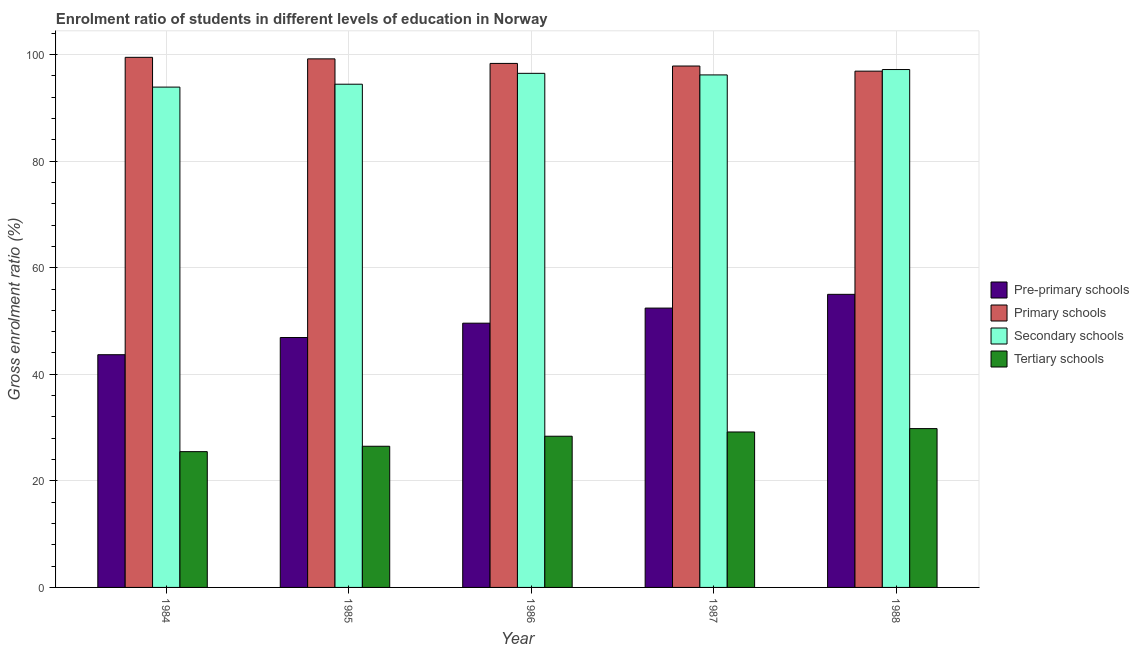How many groups of bars are there?
Offer a terse response. 5. How many bars are there on the 3rd tick from the left?
Give a very brief answer. 4. How many bars are there on the 3rd tick from the right?
Ensure brevity in your answer.  4. What is the label of the 4th group of bars from the left?
Keep it short and to the point. 1987. In how many cases, is the number of bars for a given year not equal to the number of legend labels?
Provide a succinct answer. 0. What is the gross enrolment ratio in tertiary schools in 1987?
Provide a succinct answer. 29.17. Across all years, what is the maximum gross enrolment ratio in primary schools?
Offer a very short reply. 99.49. Across all years, what is the minimum gross enrolment ratio in secondary schools?
Your answer should be compact. 93.91. What is the total gross enrolment ratio in primary schools in the graph?
Give a very brief answer. 491.81. What is the difference between the gross enrolment ratio in pre-primary schools in 1984 and that in 1985?
Offer a very short reply. -3.23. What is the difference between the gross enrolment ratio in primary schools in 1984 and the gross enrolment ratio in tertiary schools in 1987?
Provide a succinct answer. 1.63. What is the average gross enrolment ratio in secondary schools per year?
Offer a very short reply. 95.65. In the year 1984, what is the difference between the gross enrolment ratio in secondary schools and gross enrolment ratio in pre-primary schools?
Keep it short and to the point. 0. In how many years, is the gross enrolment ratio in primary schools greater than 20 %?
Your answer should be compact. 5. What is the ratio of the gross enrolment ratio in secondary schools in 1984 to that in 1985?
Give a very brief answer. 0.99. Is the difference between the gross enrolment ratio in tertiary schools in 1984 and 1988 greater than the difference between the gross enrolment ratio in primary schools in 1984 and 1988?
Your answer should be compact. No. What is the difference between the highest and the second highest gross enrolment ratio in tertiary schools?
Provide a short and direct response. 0.64. What is the difference between the highest and the lowest gross enrolment ratio in pre-primary schools?
Your answer should be compact. 11.33. In how many years, is the gross enrolment ratio in secondary schools greater than the average gross enrolment ratio in secondary schools taken over all years?
Offer a terse response. 3. Is it the case that in every year, the sum of the gross enrolment ratio in pre-primary schools and gross enrolment ratio in primary schools is greater than the sum of gross enrolment ratio in tertiary schools and gross enrolment ratio in secondary schools?
Provide a succinct answer. Yes. What does the 2nd bar from the left in 1987 represents?
Provide a short and direct response. Primary schools. What does the 4th bar from the right in 1984 represents?
Your answer should be very brief. Pre-primary schools. Is it the case that in every year, the sum of the gross enrolment ratio in pre-primary schools and gross enrolment ratio in primary schools is greater than the gross enrolment ratio in secondary schools?
Your answer should be compact. Yes. Are the values on the major ticks of Y-axis written in scientific E-notation?
Keep it short and to the point. No. Does the graph contain grids?
Give a very brief answer. Yes. Where does the legend appear in the graph?
Provide a short and direct response. Center right. How are the legend labels stacked?
Your answer should be very brief. Vertical. What is the title of the graph?
Keep it short and to the point. Enrolment ratio of students in different levels of education in Norway. What is the Gross enrolment ratio (%) of Pre-primary schools in 1984?
Offer a terse response. 43.68. What is the Gross enrolment ratio (%) of Primary schools in 1984?
Provide a succinct answer. 99.49. What is the Gross enrolment ratio (%) in Secondary schools in 1984?
Give a very brief answer. 93.91. What is the Gross enrolment ratio (%) in Tertiary schools in 1984?
Offer a very short reply. 25.48. What is the Gross enrolment ratio (%) in Pre-primary schools in 1985?
Give a very brief answer. 46.9. What is the Gross enrolment ratio (%) of Primary schools in 1985?
Your answer should be compact. 99.2. What is the Gross enrolment ratio (%) of Secondary schools in 1985?
Your response must be concise. 94.45. What is the Gross enrolment ratio (%) of Tertiary schools in 1985?
Your answer should be very brief. 26.5. What is the Gross enrolment ratio (%) of Pre-primary schools in 1986?
Give a very brief answer. 49.6. What is the Gross enrolment ratio (%) in Primary schools in 1986?
Your answer should be very brief. 98.35. What is the Gross enrolment ratio (%) of Secondary schools in 1986?
Give a very brief answer. 96.49. What is the Gross enrolment ratio (%) of Tertiary schools in 1986?
Provide a succinct answer. 28.38. What is the Gross enrolment ratio (%) of Pre-primary schools in 1987?
Your answer should be very brief. 52.43. What is the Gross enrolment ratio (%) of Primary schools in 1987?
Offer a very short reply. 97.86. What is the Gross enrolment ratio (%) of Secondary schools in 1987?
Keep it short and to the point. 96.19. What is the Gross enrolment ratio (%) in Tertiary schools in 1987?
Your response must be concise. 29.17. What is the Gross enrolment ratio (%) of Pre-primary schools in 1988?
Keep it short and to the point. 55.01. What is the Gross enrolment ratio (%) of Primary schools in 1988?
Ensure brevity in your answer.  96.9. What is the Gross enrolment ratio (%) in Secondary schools in 1988?
Your answer should be compact. 97.2. What is the Gross enrolment ratio (%) of Tertiary schools in 1988?
Provide a short and direct response. 29.81. Across all years, what is the maximum Gross enrolment ratio (%) of Pre-primary schools?
Keep it short and to the point. 55.01. Across all years, what is the maximum Gross enrolment ratio (%) in Primary schools?
Offer a very short reply. 99.49. Across all years, what is the maximum Gross enrolment ratio (%) of Secondary schools?
Give a very brief answer. 97.2. Across all years, what is the maximum Gross enrolment ratio (%) in Tertiary schools?
Your answer should be very brief. 29.81. Across all years, what is the minimum Gross enrolment ratio (%) in Pre-primary schools?
Provide a short and direct response. 43.68. Across all years, what is the minimum Gross enrolment ratio (%) of Primary schools?
Your answer should be compact. 96.9. Across all years, what is the minimum Gross enrolment ratio (%) in Secondary schools?
Provide a succinct answer. 93.91. Across all years, what is the minimum Gross enrolment ratio (%) of Tertiary schools?
Your response must be concise. 25.48. What is the total Gross enrolment ratio (%) of Pre-primary schools in the graph?
Make the answer very short. 247.62. What is the total Gross enrolment ratio (%) of Primary schools in the graph?
Your answer should be very brief. 491.81. What is the total Gross enrolment ratio (%) in Secondary schools in the graph?
Your response must be concise. 478.23. What is the total Gross enrolment ratio (%) of Tertiary schools in the graph?
Keep it short and to the point. 139.34. What is the difference between the Gross enrolment ratio (%) of Pre-primary schools in 1984 and that in 1985?
Offer a terse response. -3.23. What is the difference between the Gross enrolment ratio (%) in Primary schools in 1984 and that in 1985?
Provide a succinct answer. 0.29. What is the difference between the Gross enrolment ratio (%) of Secondary schools in 1984 and that in 1985?
Your response must be concise. -0.54. What is the difference between the Gross enrolment ratio (%) in Tertiary schools in 1984 and that in 1985?
Provide a short and direct response. -1.01. What is the difference between the Gross enrolment ratio (%) of Pre-primary schools in 1984 and that in 1986?
Provide a short and direct response. -5.92. What is the difference between the Gross enrolment ratio (%) in Primary schools in 1984 and that in 1986?
Offer a terse response. 1.14. What is the difference between the Gross enrolment ratio (%) in Secondary schools in 1984 and that in 1986?
Keep it short and to the point. -2.58. What is the difference between the Gross enrolment ratio (%) in Tertiary schools in 1984 and that in 1986?
Provide a short and direct response. -2.9. What is the difference between the Gross enrolment ratio (%) in Pre-primary schools in 1984 and that in 1987?
Ensure brevity in your answer.  -8.75. What is the difference between the Gross enrolment ratio (%) in Primary schools in 1984 and that in 1987?
Offer a terse response. 1.63. What is the difference between the Gross enrolment ratio (%) in Secondary schools in 1984 and that in 1987?
Give a very brief answer. -2.29. What is the difference between the Gross enrolment ratio (%) of Tertiary schools in 1984 and that in 1987?
Make the answer very short. -3.69. What is the difference between the Gross enrolment ratio (%) in Pre-primary schools in 1984 and that in 1988?
Ensure brevity in your answer.  -11.33. What is the difference between the Gross enrolment ratio (%) in Primary schools in 1984 and that in 1988?
Ensure brevity in your answer.  2.59. What is the difference between the Gross enrolment ratio (%) of Secondary schools in 1984 and that in 1988?
Your answer should be compact. -3.29. What is the difference between the Gross enrolment ratio (%) in Tertiary schools in 1984 and that in 1988?
Your response must be concise. -4.33. What is the difference between the Gross enrolment ratio (%) in Pre-primary schools in 1985 and that in 1986?
Provide a short and direct response. -2.69. What is the difference between the Gross enrolment ratio (%) of Primary schools in 1985 and that in 1986?
Offer a very short reply. 0.85. What is the difference between the Gross enrolment ratio (%) of Secondary schools in 1985 and that in 1986?
Your answer should be compact. -2.04. What is the difference between the Gross enrolment ratio (%) of Tertiary schools in 1985 and that in 1986?
Provide a short and direct response. -1.88. What is the difference between the Gross enrolment ratio (%) of Pre-primary schools in 1985 and that in 1987?
Make the answer very short. -5.52. What is the difference between the Gross enrolment ratio (%) in Primary schools in 1985 and that in 1987?
Make the answer very short. 1.34. What is the difference between the Gross enrolment ratio (%) in Secondary schools in 1985 and that in 1987?
Make the answer very short. -1.75. What is the difference between the Gross enrolment ratio (%) of Tertiary schools in 1985 and that in 1987?
Offer a very short reply. -2.68. What is the difference between the Gross enrolment ratio (%) of Pre-primary schools in 1985 and that in 1988?
Give a very brief answer. -8.1. What is the difference between the Gross enrolment ratio (%) of Primary schools in 1985 and that in 1988?
Make the answer very short. 2.31. What is the difference between the Gross enrolment ratio (%) of Secondary schools in 1985 and that in 1988?
Your answer should be compact. -2.75. What is the difference between the Gross enrolment ratio (%) in Tertiary schools in 1985 and that in 1988?
Your answer should be compact. -3.31. What is the difference between the Gross enrolment ratio (%) in Pre-primary schools in 1986 and that in 1987?
Offer a very short reply. -2.83. What is the difference between the Gross enrolment ratio (%) of Primary schools in 1986 and that in 1987?
Provide a short and direct response. 0.49. What is the difference between the Gross enrolment ratio (%) in Secondary schools in 1986 and that in 1987?
Give a very brief answer. 0.29. What is the difference between the Gross enrolment ratio (%) of Tertiary schools in 1986 and that in 1987?
Give a very brief answer. -0.8. What is the difference between the Gross enrolment ratio (%) of Pre-primary schools in 1986 and that in 1988?
Keep it short and to the point. -5.41. What is the difference between the Gross enrolment ratio (%) of Primary schools in 1986 and that in 1988?
Your answer should be compact. 1.45. What is the difference between the Gross enrolment ratio (%) of Secondary schools in 1986 and that in 1988?
Give a very brief answer. -0.71. What is the difference between the Gross enrolment ratio (%) of Tertiary schools in 1986 and that in 1988?
Make the answer very short. -1.43. What is the difference between the Gross enrolment ratio (%) of Pre-primary schools in 1987 and that in 1988?
Your answer should be compact. -2.58. What is the difference between the Gross enrolment ratio (%) in Primary schools in 1987 and that in 1988?
Your answer should be compact. 0.96. What is the difference between the Gross enrolment ratio (%) of Secondary schools in 1987 and that in 1988?
Your answer should be compact. -1.01. What is the difference between the Gross enrolment ratio (%) of Tertiary schools in 1987 and that in 1988?
Your answer should be very brief. -0.64. What is the difference between the Gross enrolment ratio (%) of Pre-primary schools in 1984 and the Gross enrolment ratio (%) of Primary schools in 1985?
Keep it short and to the point. -55.53. What is the difference between the Gross enrolment ratio (%) in Pre-primary schools in 1984 and the Gross enrolment ratio (%) in Secondary schools in 1985?
Ensure brevity in your answer.  -50.77. What is the difference between the Gross enrolment ratio (%) in Pre-primary schools in 1984 and the Gross enrolment ratio (%) in Tertiary schools in 1985?
Offer a terse response. 17.18. What is the difference between the Gross enrolment ratio (%) of Primary schools in 1984 and the Gross enrolment ratio (%) of Secondary schools in 1985?
Offer a terse response. 5.04. What is the difference between the Gross enrolment ratio (%) in Primary schools in 1984 and the Gross enrolment ratio (%) in Tertiary schools in 1985?
Your answer should be compact. 73. What is the difference between the Gross enrolment ratio (%) in Secondary schools in 1984 and the Gross enrolment ratio (%) in Tertiary schools in 1985?
Ensure brevity in your answer.  67.41. What is the difference between the Gross enrolment ratio (%) of Pre-primary schools in 1984 and the Gross enrolment ratio (%) of Primary schools in 1986?
Offer a very short reply. -54.67. What is the difference between the Gross enrolment ratio (%) of Pre-primary schools in 1984 and the Gross enrolment ratio (%) of Secondary schools in 1986?
Make the answer very short. -52.81. What is the difference between the Gross enrolment ratio (%) of Pre-primary schools in 1984 and the Gross enrolment ratio (%) of Tertiary schools in 1986?
Your answer should be compact. 15.3. What is the difference between the Gross enrolment ratio (%) in Primary schools in 1984 and the Gross enrolment ratio (%) in Secondary schools in 1986?
Provide a short and direct response. 3.01. What is the difference between the Gross enrolment ratio (%) in Primary schools in 1984 and the Gross enrolment ratio (%) in Tertiary schools in 1986?
Provide a short and direct response. 71.11. What is the difference between the Gross enrolment ratio (%) of Secondary schools in 1984 and the Gross enrolment ratio (%) of Tertiary schools in 1986?
Your response must be concise. 65.53. What is the difference between the Gross enrolment ratio (%) in Pre-primary schools in 1984 and the Gross enrolment ratio (%) in Primary schools in 1987?
Ensure brevity in your answer.  -54.18. What is the difference between the Gross enrolment ratio (%) of Pre-primary schools in 1984 and the Gross enrolment ratio (%) of Secondary schools in 1987?
Make the answer very short. -52.51. What is the difference between the Gross enrolment ratio (%) of Pre-primary schools in 1984 and the Gross enrolment ratio (%) of Tertiary schools in 1987?
Keep it short and to the point. 14.5. What is the difference between the Gross enrolment ratio (%) of Primary schools in 1984 and the Gross enrolment ratio (%) of Secondary schools in 1987?
Provide a succinct answer. 3.3. What is the difference between the Gross enrolment ratio (%) in Primary schools in 1984 and the Gross enrolment ratio (%) in Tertiary schools in 1987?
Offer a terse response. 70.32. What is the difference between the Gross enrolment ratio (%) in Secondary schools in 1984 and the Gross enrolment ratio (%) in Tertiary schools in 1987?
Provide a short and direct response. 64.73. What is the difference between the Gross enrolment ratio (%) in Pre-primary schools in 1984 and the Gross enrolment ratio (%) in Primary schools in 1988?
Ensure brevity in your answer.  -53.22. What is the difference between the Gross enrolment ratio (%) of Pre-primary schools in 1984 and the Gross enrolment ratio (%) of Secondary schools in 1988?
Give a very brief answer. -53.52. What is the difference between the Gross enrolment ratio (%) in Pre-primary schools in 1984 and the Gross enrolment ratio (%) in Tertiary schools in 1988?
Keep it short and to the point. 13.87. What is the difference between the Gross enrolment ratio (%) of Primary schools in 1984 and the Gross enrolment ratio (%) of Secondary schools in 1988?
Your answer should be compact. 2.29. What is the difference between the Gross enrolment ratio (%) of Primary schools in 1984 and the Gross enrolment ratio (%) of Tertiary schools in 1988?
Your response must be concise. 69.68. What is the difference between the Gross enrolment ratio (%) of Secondary schools in 1984 and the Gross enrolment ratio (%) of Tertiary schools in 1988?
Your answer should be compact. 64.1. What is the difference between the Gross enrolment ratio (%) in Pre-primary schools in 1985 and the Gross enrolment ratio (%) in Primary schools in 1986?
Your response must be concise. -51.45. What is the difference between the Gross enrolment ratio (%) in Pre-primary schools in 1985 and the Gross enrolment ratio (%) in Secondary schools in 1986?
Offer a very short reply. -49.58. What is the difference between the Gross enrolment ratio (%) of Pre-primary schools in 1985 and the Gross enrolment ratio (%) of Tertiary schools in 1986?
Ensure brevity in your answer.  18.53. What is the difference between the Gross enrolment ratio (%) of Primary schools in 1985 and the Gross enrolment ratio (%) of Secondary schools in 1986?
Provide a short and direct response. 2.72. What is the difference between the Gross enrolment ratio (%) of Primary schools in 1985 and the Gross enrolment ratio (%) of Tertiary schools in 1986?
Keep it short and to the point. 70.82. What is the difference between the Gross enrolment ratio (%) of Secondary schools in 1985 and the Gross enrolment ratio (%) of Tertiary schools in 1986?
Offer a very short reply. 66.07. What is the difference between the Gross enrolment ratio (%) in Pre-primary schools in 1985 and the Gross enrolment ratio (%) in Primary schools in 1987?
Provide a succinct answer. -50.96. What is the difference between the Gross enrolment ratio (%) in Pre-primary schools in 1985 and the Gross enrolment ratio (%) in Secondary schools in 1987?
Your answer should be very brief. -49.29. What is the difference between the Gross enrolment ratio (%) in Pre-primary schools in 1985 and the Gross enrolment ratio (%) in Tertiary schools in 1987?
Provide a succinct answer. 17.73. What is the difference between the Gross enrolment ratio (%) of Primary schools in 1985 and the Gross enrolment ratio (%) of Secondary schools in 1987?
Offer a very short reply. 3.01. What is the difference between the Gross enrolment ratio (%) in Primary schools in 1985 and the Gross enrolment ratio (%) in Tertiary schools in 1987?
Your answer should be compact. 70.03. What is the difference between the Gross enrolment ratio (%) in Secondary schools in 1985 and the Gross enrolment ratio (%) in Tertiary schools in 1987?
Your response must be concise. 65.27. What is the difference between the Gross enrolment ratio (%) in Pre-primary schools in 1985 and the Gross enrolment ratio (%) in Primary schools in 1988?
Your response must be concise. -49.99. What is the difference between the Gross enrolment ratio (%) of Pre-primary schools in 1985 and the Gross enrolment ratio (%) of Secondary schools in 1988?
Provide a short and direct response. -50.3. What is the difference between the Gross enrolment ratio (%) in Pre-primary schools in 1985 and the Gross enrolment ratio (%) in Tertiary schools in 1988?
Your response must be concise. 17.09. What is the difference between the Gross enrolment ratio (%) of Primary schools in 1985 and the Gross enrolment ratio (%) of Secondary schools in 1988?
Offer a very short reply. 2. What is the difference between the Gross enrolment ratio (%) in Primary schools in 1985 and the Gross enrolment ratio (%) in Tertiary schools in 1988?
Provide a short and direct response. 69.39. What is the difference between the Gross enrolment ratio (%) in Secondary schools in 1985 and the Gross enrolment ratio (%) in Tertiary schools in 1988?
Your answer should be compact. 64.64. What is the difference between the Gross enrolment ratio (%) of Pre-primary schools in 1986 and the Gross enrolment ratio (%) of Primary schools in 1987?
Ensure brevity in your answer.  -48.27. What is the difference between the Gross enrolment ratio (%) of Pre-primary schools in 1986 and the Gross enrolment ratio (%) of Secondary schools in 1987?
Offer a terse response. -46.6. What is the difference between the Gross enrolment ratio (%) in Pre-primary schools in 1986 and the Gross enrolment ratio (%) in Tertiary schools in 1987?
Ensure brevity in your answer.  20.42. What is the difference between the Gross enrolment ratio (%) in Primary schools in 1986 and the Gross enrolment ratio (%) in Secondary schools in 1987?
Keep it short and to the point. 2.16. What is the difference between the Gross enrolment ratio (%) in Primary schools in 1986 and the Gross enrolment ratio (%) in Tertiary schools in 1987?
Give a very brief answer. 69.18. What is the difference between the Gross enrolment ratio (%) of Secondary schools in 1986 and the Gross enrolment ratio (%) of Tertiary schools in 1987?
Your response must be concise. 67.31. What is the difference between the Gross enrolment ratio (%) in Pre-primary schools in 1986 and the Gross enrolment ratio (%) in Primary schools in 1988?
Your answer should be very brief. -47.3. What is the difference between the Gross enrolment ratio (%) in Pre-primary schools in 1986 and the Gross enrolment ratio (%) in Secondary schools in 1988?
Provide a short and direct response. -47.6. What is the difference between the Gross enrolment ratio (%) of Pre-primary schools in 1986 and the Gross enrolment ratio (%) of Tertiary schools in 1988?
Your answer should be compact. 19.79. What is the difference between the Gross enrolment ratio (%) in Primary schools in 1986 and the Gross enrolment ratio (%) in Secondary schools in 1988?
Offer a terse response. 1.15. What is the difference between the Gross enrolment ratio (%) of Primary schools in 1986 and the Gross enrolment ratio (%) of Tertiary schools in 1988?
Provide a succinct answer. 68.54. What is the difference between the Gross enrolment ratio (%) in Secondary schools in 1986 and the Gross enrolment ratio (%) in Tertiary schools in 1988?
Your answer should be very brief. 66.68. What is the difference between the Gross enrolment ratio (%) in Pre-primary schools in 1987 and the Gross enrolment ratio (%) in Primary schools in 1988?
Your answer should be compact. -44.47. What is the difference between the Gross enrolment ratio (%) of Pre-primary schools in 1987 and the Gross enrolment ratio (%) of Secondary schools in 1988?
Your response must be concise. -44.77. What is the difference between the Gross enrolment ratio (%) in Pre-primary schools in 1987 and the Gross enrolment ratio (%) in Tertiary schools in 1988?
Offer a very short reply. 22.62. What is the difference between the Gross enrolment ratio (%) in Primary schools in 1987 and the Gross enrolment ratio (%) in Secondary schools in 1988?
Your answer should be compact. 0.66. What is the difference between the Gross enrolment ratio (%) in Primary schools in 1987 and the Gross enrolment ratio (%) in Tertiary schools in 1988?
Offer a terse response. 68.05. What is the difference between the Gross enrolment ratio (%) of Secondary schools in 1987 and the Gross enrolment ratio (%) of Tertiary schools in 1988?
Offer a very short reply. 66.38. What is the average Gross enrolment ratio (%) of Pre-primary schools per year?
Provide a short and direct response. 49.52. What is the average Gross enrolment ratio (%) of Primary schools per year?
Your answer should be compact. 98.36. What is the average Gross enrolment ratio (%) in Secondary schools per year?
Keep it short and to the point. 95.65. What is the average Gross enrolment ratio (%) of Tertiary schools per year?
Make the answer very short. 27.87. In the year 1984, what is the difference between the Gross enrolment ratio (%) in Pre-primary schools and Gross enrolment ratio (%) in Primary schools?
Keep it short and to the point. -55.81. In the year 1984, what is the difference between the Gross enrolment ratio (%) of Pre-primary schools and Gross enrolment ratio (%) of Secondary schools?
Your answer should be compact. -50.23. In the year 1984, what is the difference between the Gross enrolment ratio (%) of Pre-primary schools and Gross enrolment ratio (%) of Tertiary schools?
Offer a terse response. 18.19. In the year 1984, what is the difference between the Gross enrolment ratio (%) of Primary schools and Gross enrolment ratio (%) of Secondary schools?
Give a very brief answer. 5.59. In the year 1984, what is the difference between the Gross enrolment ratio (%) in Primary schools and Gross enrolment ratio (%) in Tertiary schools?
Provide a succinct answer. 74.01. In the year 1984, what is the difference between the Gross enrolment ratio (%) in Secondary schools and Gross enrolment ratio (%) in Tertiary schools?
Your response must be concise. 68.42. In the year 1985, what is the difference between the Gross enrolment ratio (%) of Pre-primary schools and Gross enrolment ratio (%) of Primary schools?
Offer a very short reply. -52.3. In the year 1985, what is the difference between the Gross enrolment ratio (%) in Pre-primary schools and Gross enrolment ratio (%) in Secondary schools?
Provide a succinct answer. -47.54. In the year 1985, what is the difference between the Gross enrolment ratio (%) of Pre-primary schools and Gross enrolment ratio (%) of Tertiary schools?
Make the answer very short. 20.41. In the year 1985, what is the difference between the Gross enrolment ratio (%) in Primary schools and Gross enrolment ratio (%) in Secondary schools?
Your answer should be very brief. 4.76. In the year 1985, what is the difference between the Gross enrolment ratio (%) of Primary schools and Gross enrolment ratio (%) of Tertiary schools?
Offer a very short reply. 72.71. In the year 1985, what is the difference between the Gross enrolment ratio (%) of Secondary schools and Gross enrolment ratio (%) of Tertiary schools?
Provide a short and direct response. 67.95. In the year 1986, what is the difference between the Gross enrolment ratio (%) of Pre-primary schools and Gross enrolment ratio (%) of Primary schools?
Offer a terse response. -48.75. In the year 1986, what is the difference between the Gross enrolment ratio (%) in Pre-primary schools and Gross enrolment ratio (%) in Secondary schools?
Your answer should be compact. -46.89. In the year 1986, what is the difference between the Gross enrolment ratio (%) of Pre-primary schools and Gross enrolment ratio (%) of Tertiary schools?
Provide a short and direct response. 21.22. In the year 1986, what is the difference between the Gross enrolment ratio (%) of Primary schools and Gross enrolment ratio (%) of Secondary schools?
Your answer should be very brief. 1.86. In the year 1986, what is the difference between the Gross enrolment ratio (%) of Primary schools and Gross enrolment ratio (%) of Tertiary schools?
Ensure brevity in your answer.  69.97. In the year 1986, what is the difference between the Gross enrolment ratio (%) of Secondary schools and Gross enrolment ratio (%) of Tertiary schools?
Ensure brevity in your answer.  68.11. In the year 1987, what is the difference between the Gross enrolment ratio (%) in Pre-primary schools and Gross enrolment ratio (%) in Primary schools?
Offer a very short reply. -45.43. In the year 1987, what is the difference between the Gross enrolment ratio (%) of Pre-primary schools and Gross enrolment ratio (%) of Secondary schools?
Ensure brevity in your answer.  -43.76. In the year 1987, what is the difference between the Gross enrolment ratio (%) in Pre-primary schools and Gross enrolment ratio (%) in Tertiary schools?
Give a very brief answer. 23.25. In the year 1987, what is the difference between the Gross enrolment ratio (%) in Primary schools and Gross enrolment ratio (%) in Secondary schools?
Provide a succinct answer. 1.67. In the year 1987, what is the difference between the Gross enrolment ratio (%) in Primary schools and Gross enrolment ratio (%) in Tertiary schools?
Your response must be concise. 68.69. In the year 1987, what is the difference between the Gross enrolment ratio (%) in Secondary schools and Gross enrolment ratio (%) in Tertiary schools?
Your answer should be very brief. 67.02. In the year 1988, what is the difference between the Gross enrolment ratio (%) in Pre-primary schools and Gross enrolment ratio (%) in Primary schools?
Give a very brief answer. -41.89. In the year 1988, what is the difference between the Gross enrolment ratio (%) of Pre-primary schools and Gross enrolment ratio (%) of Secondary schools?
Provide a short and direct response. -42.19. In the year 1988, what is the difference between the Gross enrolment ratio (%) in Pre-primary schools and Gross enrolment ratio (%) in Tertiary schools?
Make the answer very short. 25.2. In the year 1988, what is the difference between the Gross enrolment ratio (%) of Primary schools and Gross enrolment ratio (%) of Secondary schools?
Your response must be concise. -0.3. In the year 1988, what is the difference between the Gross enrolment ratio (%) in Primary schools and Gross enrolment ratio (%) in Tertiary schools?
Your answer should be very brief. 67.09. In the year 1988, what is the difference between the Gross enrolment ratio (%) of Secondary schools and Gross enrolment ratio (%) of Tertiary schools?
Your response must be concise. 67.39. What is the ratio of the Gross enrolment ratio (%) of Pre-primary schools in 1984 to that in 1985?
Make the answer very short. 0.93. What is the ratio of the Gross enrolment ratio (%) of Primary schools in 1984 to that in 1985?
Provide a succinct answer. 1. What is the ratio of the Gross enrolment ratio (%) in Secondary schools in 1984 to that in 1985?
Offer a terse response. 0.99. What is the ratio of the Gross enrolment ratio (%) of Tertiary schools in 1984 to that in 1985?
Provide a succinct answer. 0.96. What is the ratio of the Gross enrolment ratio (%) of Pre-primary schools in 1984 to that in 1986?
Offer a very short reply. 0.88. What is the ratio of the Gross enrolment ratio (%) in Primary schools in 1984 to that in 1986?
Your answer should be compact. 1.01. What is the ratio of the Gross enrolment ratio (%) of Secondary schools in 1984 to that in 1986?
Your response must be concise. 0.97. What is the ratio of the Gross enrolment ratio (%) of Tertiary schools in 1984 to that in 1986?
Your answer should be compact. 0.9. What is the ratio of the Gross enrolment ratio (%) in Pre-primary schools in 1984 to that in 1987?
Your response must be concise. 0.83. What is the ratio of the Gross enrolment ratio (%) in Primary schools in 1984 to that in 1987?
Ensure brevity in your answer.  1.02. What is the ratio of the Gross enrolment ratio (%) of Secondary schools in 1984 to that in 1987?
Keep it short and to the point. 0.98. What is the ratio of the Gross enrolment ratio (%) in Tertiary schools in 1984 to that in 1987?
Give a very brief answer. 0.87. What is the ratio of the Gross enrolment ratio (%) of Pre-primary schools in 1984 to that in 1988?
Offer a very short reply. 0.79. What is the ratio of the Gross enrolment ratio (%) of Primary schools in 1984 to that in 1988?
Make the answer very short. 1.03. What is the ratio of the Gross enrolment ratio (%) in Secondary schools in 1984 to that in 1988?
Give a very brief answer. 0.97. What is the ratio of the Gross enrolment ratio (%) in Tertiary schools in 1984 to that in 1988?
Offer a terse response. 0.85. What is the ratio of the Gross enrolment ratio (%) of Pre-primary schools in 1985 to that in 1986?
Offer a terse response. 0.95. What is the ratio of the Gross enrolment ratio (%) in Primary schools in 1985 to that in 1986?
Ensure brevity in your answer.  1.01. What is the ratio of the Gross enrolment ratio (%) of Secondary schools in 1985 to that in 1986?
Provide a short and direct response. 0.98. What is the ratio of the Gross enrolment ratio (%) in Tertiary schools in 1985 to that in 1986?
Ensure brevity in your answer.  0.93. What is the ratio of the Gross enrolment ratio (%) of Pre-primary schools in 1985 to that in 1987?
Provide a succinct answer. 0.89. What is the ratio of the Gross enrolment ratio (%) in Primary schools in 1985 to that in 1987?
Provide a short and direct response. 1.01. What is the ratio of the Gross enrolment ratio (%) in Secondary schools in 1985 to that in 1987?
Your answer should be very brief. 0.98. What is the ratio of the Gross enrolment ratio (%) in Tertiary schools in 1985 to that in 1987?
Ensure brevity in your answer.  0.91. What is the ratio of the Gross enrolment ratio (%) of Pre-primary schools in 1985 to that in 1988?
Provide a succinct answer. 0.85. What is the ratio of the Gross enrolment ratio (%) in Primary schools in 1985 to that in 1988?
Ensure brevity in your answer.  1.02. What is the ratio of the Gross enrolment ratio (%) of Secondary schools in 1985 to that in 1988?
Your answer should be compact. 0.97. What is the ratio of the Gross enrolment ratio (%) of Pre-primary schools in 1986 to that in 1987?
Provide a short and direct response. 0.95. What is the ratio of the Gross enrolment ratio (%) of Primary schools in 1986 to that in 1987?
Offer a very short reply. 1. What is the ratio of the Gross enrolment ratio (%) of Tertiary schools in 1986 to that in 1987?
Your answer should be compact. 0.97. What is the ratio of the Gross enrolment ratio (%) in Pre-primary schools in 1986 to that in 1988?
Offer a terse response. 0.9. What is the ratio of the Gross enrolment ratio (%) in Primary schools in 1986 to that in 1988?
Provide a short and direct response. 1.01. What is the ratio of the Gross enrolment ratio (%) of Tertiary schools in 1986 to that in 1988?
Ensure brevity in your answer.  0.95. What is the ratio of the Gross enrolment ratio (%) in Pre-primary schools in 1987 to that in 1988?
Provide a succinct answer. 0.95. What is the ratio of the Gross enrolment ratio (%) in Primary schools in 1987 to that in 1988?
Provide a succinct answer. 1.01. What is the ratio of the Gross enrolment ratio (%) in Secondary schools in 1987 to that in 1988?
Make the answer very short. 0.99. What is the ratio of the Gross enrolment ratio (%) in Tertiary schools in 1987 to that in 1988?
Provide a succinct answer. 0.98. What is the difference between the highest and the second highest Gross enrolment ratio (%) in Pre-primary schools?
Make the answer very short. 2.58. What is the difference between the highest and the second highest Gross enrolment ratio (%) of Primary schools?
Offer a terse response. 0.29. What is the difference between the highest and the second highest Gross enrolment ratio (%) of Secondary schools?
Your answer should be very brief. 0.71. What is the difference between the highest and the second highest Gross enrolment ratio (%) in Tertiary schools?
Provide a short and direct response. 0.64. What is the difference between the highest and the lowest Gross enrolment ratio (%) of Pre-primary schools?
Give a very brief answer. 11.33. What is the difference between the highest and the lowest Gross enrolment ratio (%) in Primary schools?
Ensure brevity in your answer.  2.59. What is the difference between the highest and the lowest Gross enrolment ratio (%) in Secondary schools?
Make the answer very short. 3.29. What is the difference between the highest and the lowest Gross enrolment ratio (%) in Tertiary schools?
Your response must be concise. 4.33. 